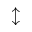<formula> <loc_0><loc_0><loc_500><loc_500>\updownarrow</formula> 